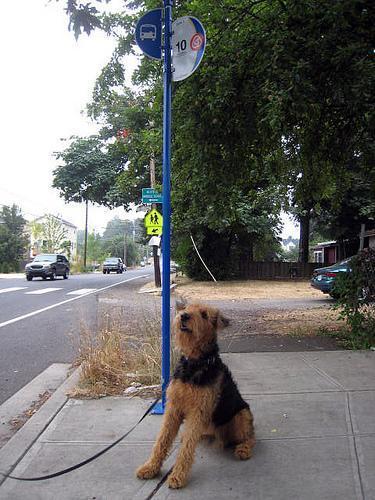How many keyboards are in the picture?
Give a very brief answer. 0. 